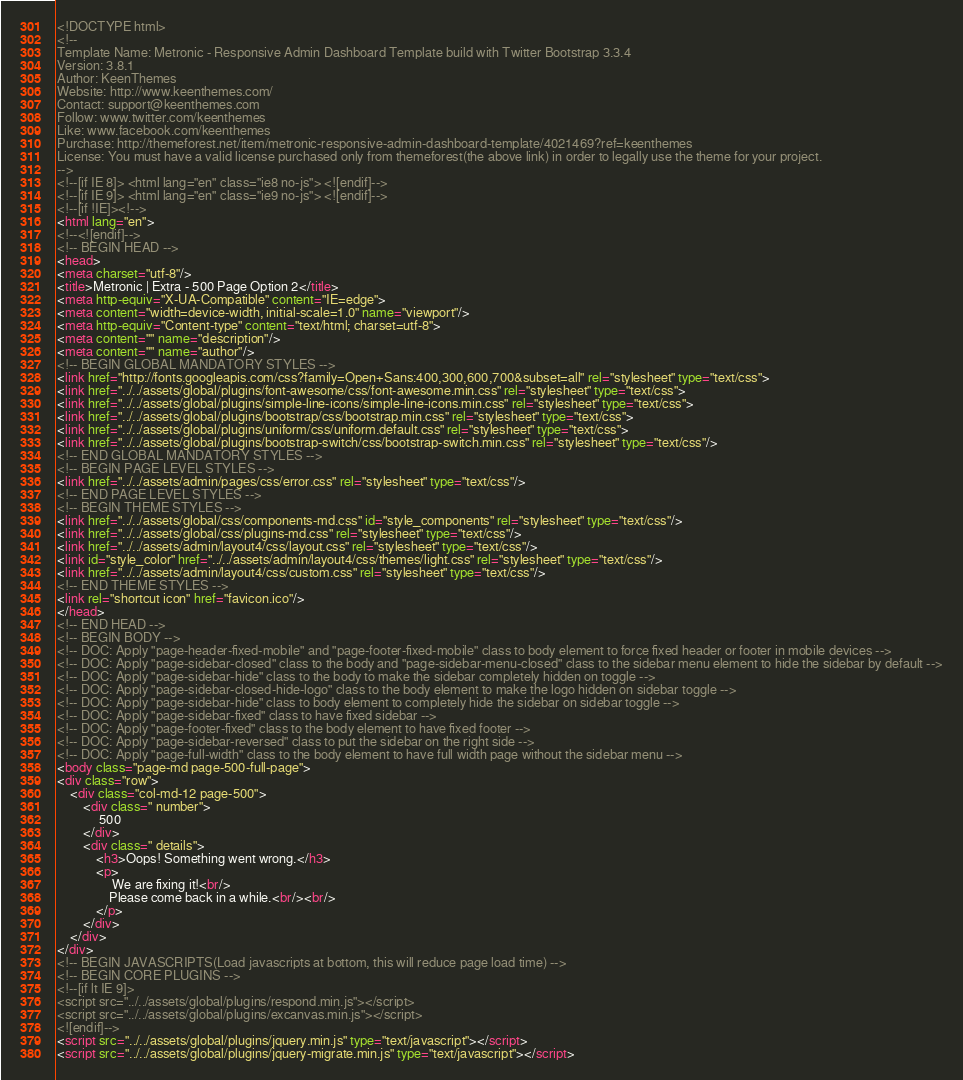Convert code to text. <code><loc_0><loc_0><loc_500><loc_500><_HTML_><!DOCTYPE html>
<!-- 
Template Name: Metronic - Responsive Admin Dashboard Template build with Twitter Bootstrap 3.3.4
Version: 3.8.1
Author: KeenThemes
Website: http://www.keenthemes.com/
Contact: support@keenthemes.com
Follow: www.twitter.com/keenthemes
Like: www.facebook.com/keenthemes
Purchase: http://themeforest.net/item/metronic-responsive-admin-dashboard-template/4021469?ref=keenthemes
License: You must have a valid license purchased only from themeforest(the above link) in order to legally use the theme for your project.
-->
<!--[if IE 8]> <html lang="en" class="ie8 no-js"> <![endif]-->
<!--[if IE 9]> <html lang="en" class="ie9 no-js"> <![endif]-->
<!--[if !IE]><!-->
<html lang="en">
<!--<![endif]-->
<!-- BEGIN HEAD -->
<head>
<meta charset="utf-8"/>
<title>Metronic | Extra - 500 Page Option 2</title>
<meta http-equiv="X-UA-Compatible" content="IE=edge">
<meta content="width=device-width, initial-scale=1.0" name="viewport"/>
<meta http-equiv="Content-type" content="text/html; charset=utf-8">
<meta content="" name="description"/>
<meta content="" name="author"/>
<!-- BEGIN GLOBAL MANDATORY STYLES -->
<link href="http://fonts.googleapis.com/css?family=Open+Sans:400,300,600,700&subset=all" rel="stylesheet" type="text/css">
<link href="../../assets/global/plugins/font-awesome/css/font-awesome.min.css" rel="stylesheet" type="text/css">
<link href="../../assets/global/plugins/simple-line-icons/simple-line-icons.min.css" rel="stylesheet" type="text/css">
<link href="../../assets/global/plugins/bootstrap/css/bootstrap.min.css" rel="stylesheet" type="text/css">
<link href="../../assets/global/plugins/uniform/css/uniform.default.css" rel="stylesheet" type="text/css">
<link href="../../assets/global/plugins/bootstrap-switch/css/bootstrap-switch.min.css" rel="stylesheet" type="text/css"/>
<!-- END GLOBAL MANDATORY STYLES -->
<!-- BEGIN PAGE LEVEL STYLES -->
<link href="../../assets/admin/pages/css/error.css" rel="stylesheet" type="text/css"/>
<!-- END PAGE LEVEL STYLES -->
<!-- BEGIN THEME STYLES -->
<link href="../../assets/global/css/components-md.css" id="style_components" rel="stylesheet" type="text/css"/>
<link href="../../assets/global/css/plugins-md.css" rel="stylesheet" type="text/css"/>
<link href="../../assets/admin/layout4/css/layout.css" rel="stylesheet" type="text/css"/>
<link id="style_color" href="../../assets/admin/layout4/css/themes/light.css" rel="stylesheet" type="text/css"/>
<link href="../../assets/admin/layout4/css/custom.css" rel="stylesheet" type="text/css"/>
<!-- END THEME STYLES -->
<link rel="shortcut icon" href="favicon.ico"/>
</head>
<!-- END HEAD -->
<!-- BEGIN BODY -->
<!-- DOC: Apply "page-header-fixed-mobile" and "page-footer-fixed-mobile" class to body element to force fixed header or footer in mobile devices -->
<!-- DOC: Apply "page-sidebar-closed" class to the body and "page-sidebar-menu-closed" class to the sidebar menu element to hide the sidebar by default -->
<!-- DOC: Apply "page-sidebar-hide" class to the body to make the sidebar completely hidden on toggle -->
<!-- DOC: Apply "page-sidebar-closed-hide-logo" class to the body element to make the logo hidden on sidebar toggle -->
<!-- DOC: Apply "page-sidebar-hide" class to body element to completely hide the sidebar on sidebar toggle -->
<!-- DOC: Apply "page-sidebar-fixed" class to have fixed sidebar -->
<!-- DOC: Apply "page-footer-fixed" class to the body element to have fixed footer -->
<!-- DOC: Apply "page-sidebar-reversed" class to put the sidebar on the right side -->
<!-- DOC: Apply "page-full-width" class to the body element to have full width page without the sidebar menu -->
<body class="page-md page-500-full-page">
<div class="row">
	<div class="col-md-12 page-500">
		<div class=" number">
			 500
		</div>
		<div class=" details">
			<h3>Oops! Something went wrong.</h3>
			<p>
				 We are fixing it!<br/>
				Please come back in a while.<br/><br/>
			</p>
		</div>
	</div>
</div>
<!-- BEGIN JAVASCRIPTS(Load javascripts at bottom, this will reduce page load time) -->
<!-- BEGIN CORE PLUGINS -->
<!--[if lt IE 9]>
<script src="../../assets/global/plugins/respond.min.js"></script>
<script src="../../assets/global/plugins/excanvas.min.js"></script> 
<![endif]-->
<script src="../../assets/global/plugins/jquery.min.js" type="text/javascript"></script>
<script src="../../assets/global/plugins/jquery-migrate.min.js" type="text/javascript"></script></code> 